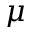<formula> <loc_0><loc_0><loc_500><loc_500>\mu</formula> 